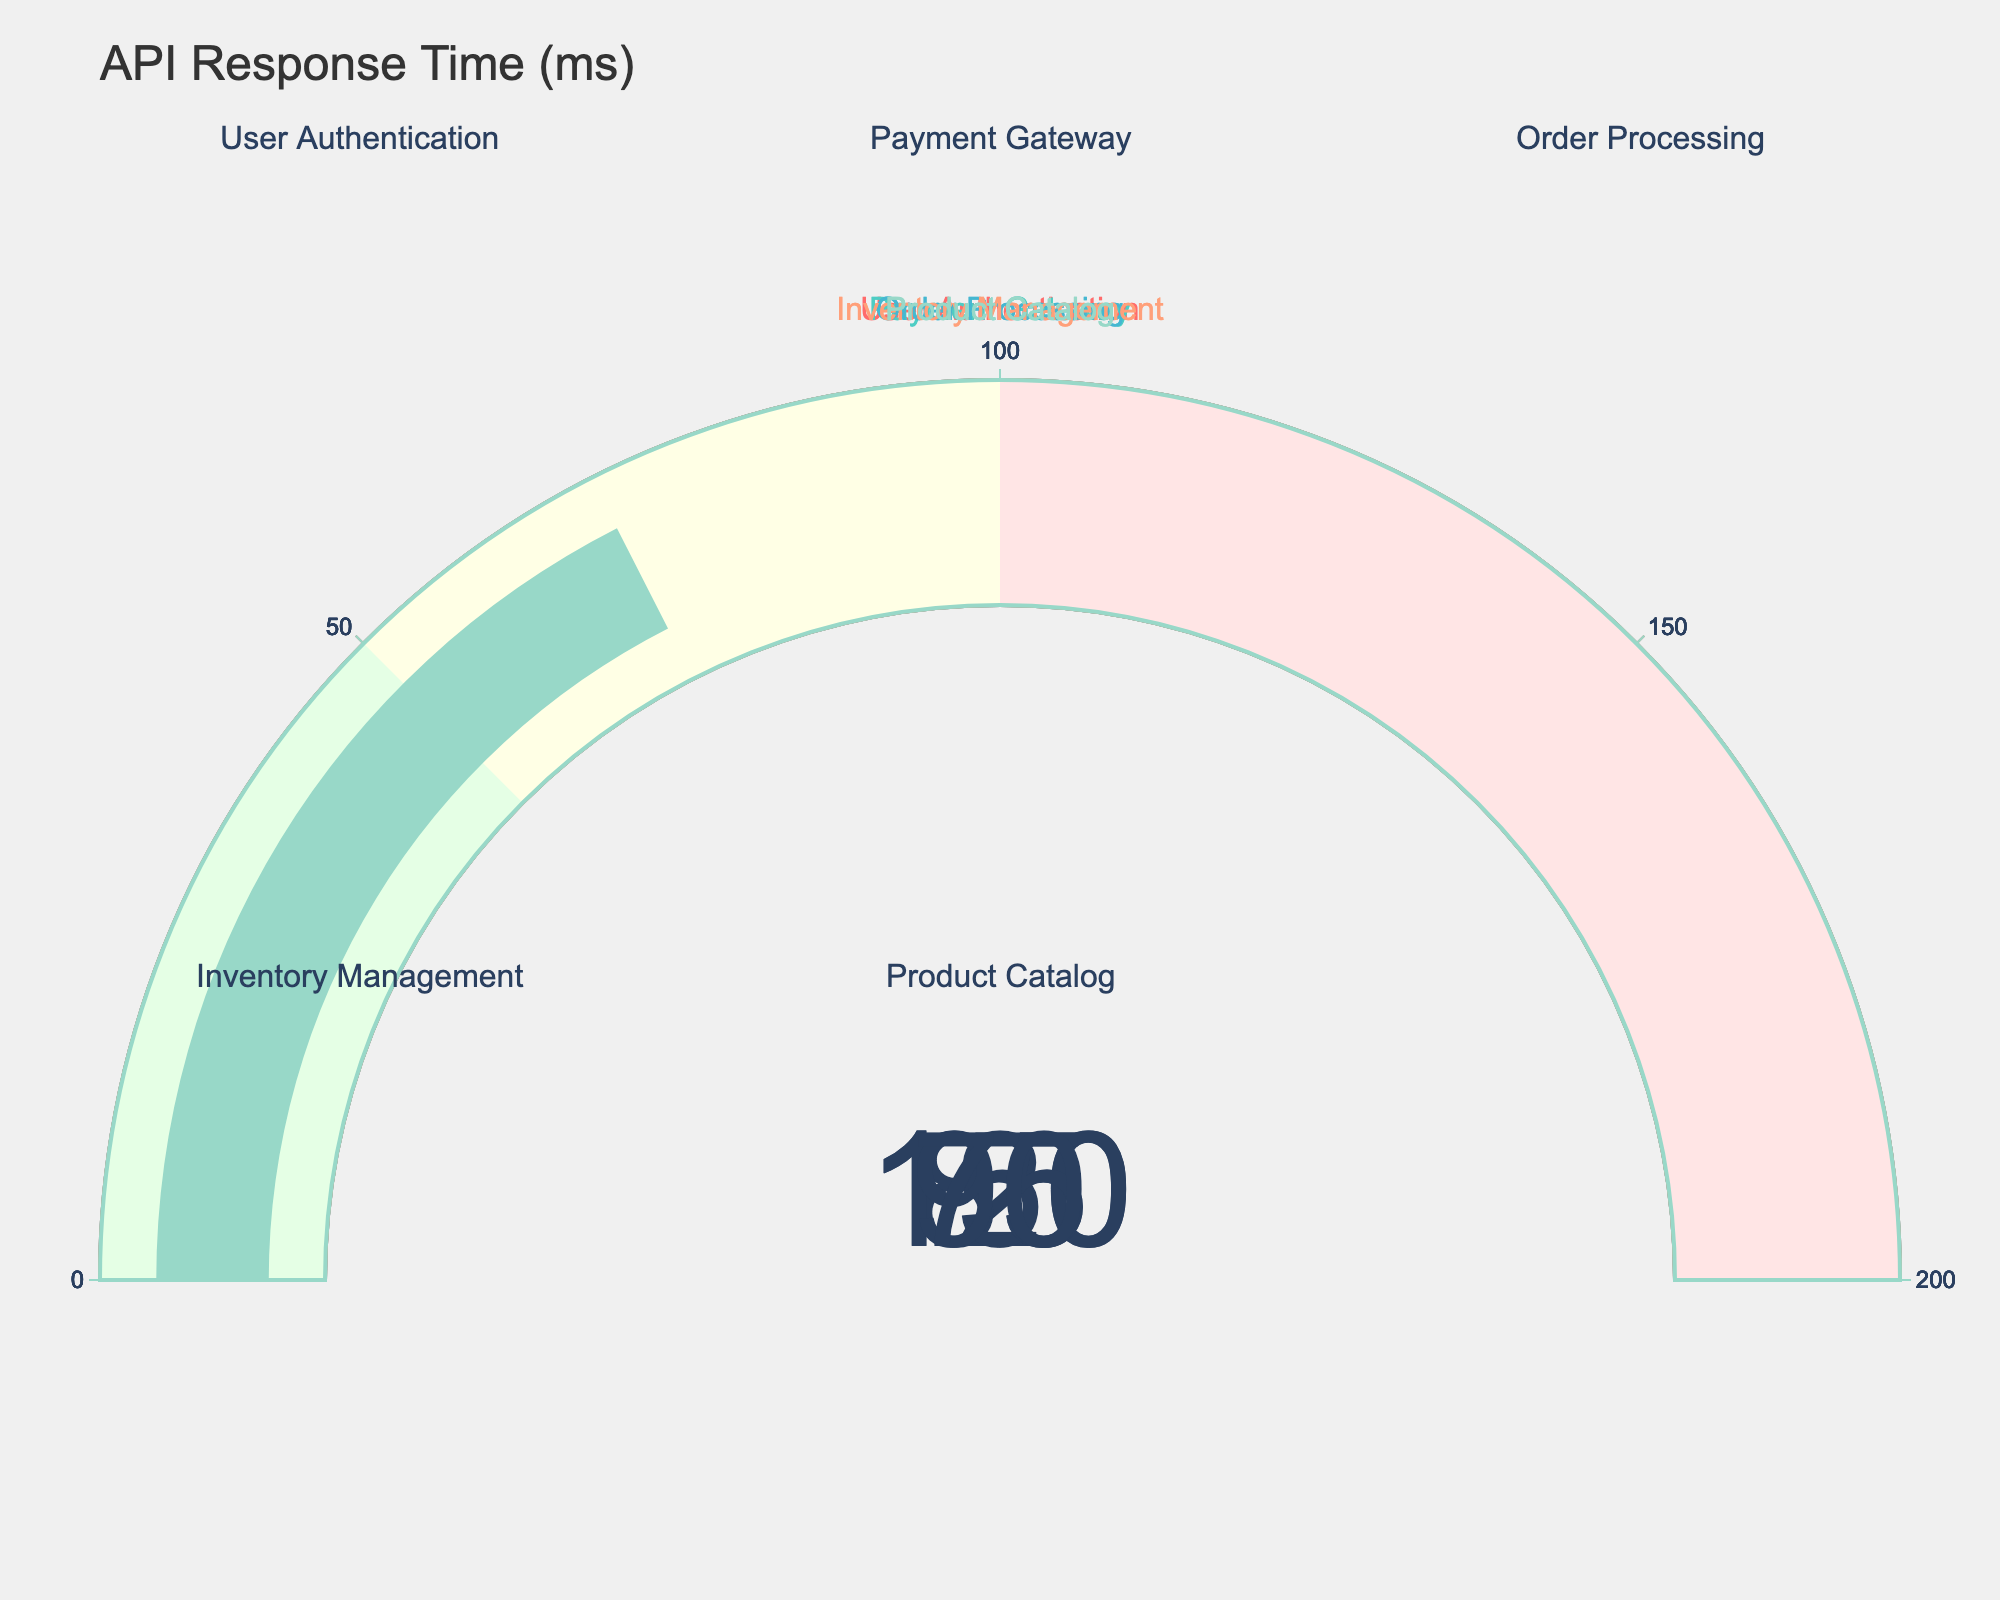How many services are displayed in the figure? There are five subplots, each representing one service. Counting each title, we can summarize that five services are depicted.
Answer: Five What is the title of the figure? The visible title at the top of the figure is "API Response Time (ms)," indicating that the gauge charts show the response times in milliseconds for the listed APIs.
Answer: API Response Time (ms) Which service has the highest response time? By examining the values shown on the gauge charts, we see that "Order Processing" has a response time of 150 milliseconds, which is the highest.
Answer: Order Processing What is the average response time of all services? Calculating the average involves summing all response times and dividing by the number of services. Sum = 120 + 85 + 150 + 95 + 70 = 520. Average = 520 / 5 = 104 ms.
Answer: 104 ms Which service has the lowest response time? The lowest response time displayed on the gauges is for the "Product Catalog" service, which is 70 milliseconds.
Answer: Product Catalog How much slower is the "User Authentication" service than the "Payment Gateway" service? Subtract the response time of "Payment Gateway" from "User Authentication": 120 - 85 = 35 ms.
Answer: 35 ms Are there any services with a response time below 90 milliseconds? By inspecting the gauge charts, we see that "Payment Gateway" (85 ms) and "Product Catalog" (70 ms) are below 90 milliseconds.
Answer: Yes Is the "Inventory Management" response time above the average response time? First, we calculated the average response time as 104 ms. "Inventory Management" has a response time of 95 ms, which is below the average.
Answer: No What is the difference in response time between the fastest and slowest services? The fastest service is "Product Catalog" at 70 ms, and the slowest is "Order Processing" at 150 ms. The difference is 150 - 70 = 80 ms.
Answer: 80 ms Which services fall into the range of 100 to 150 milliseconds? Observing the gauge charts, "User Authentication" (120 ms) and "Order Processing" (150 ms) fall within this range.
Answer: User Authentication and Order Processing 